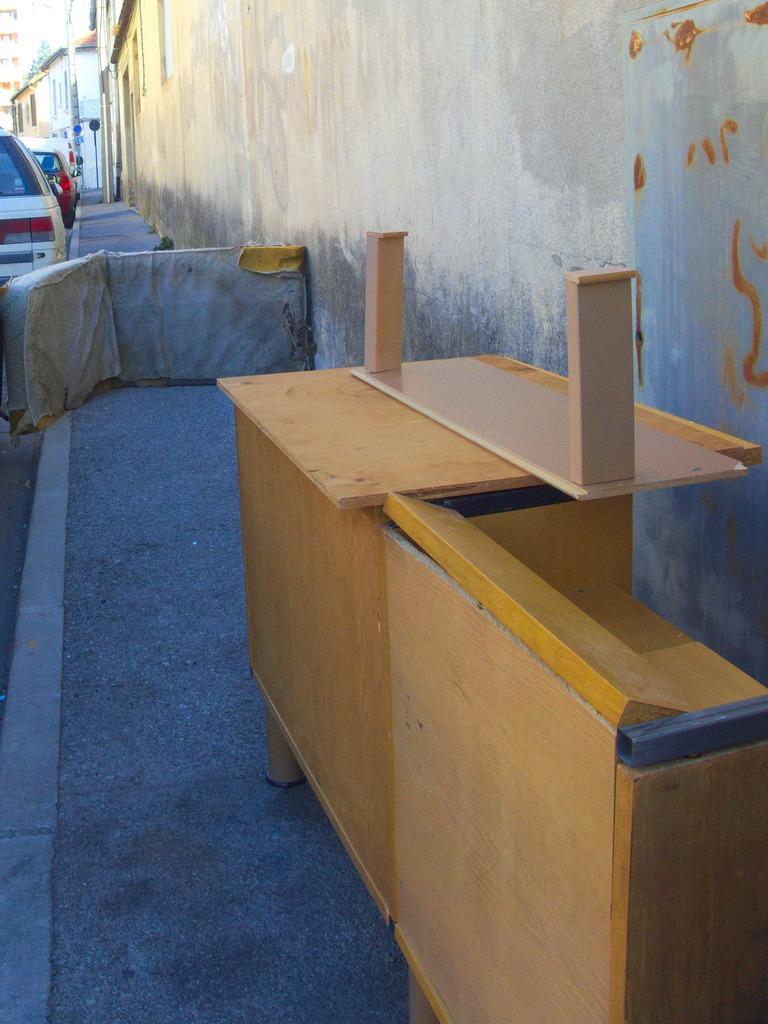Describe this image in one or two sentences. In this picture we can see vehicles on the road,beside this road we can see a table,houses. 